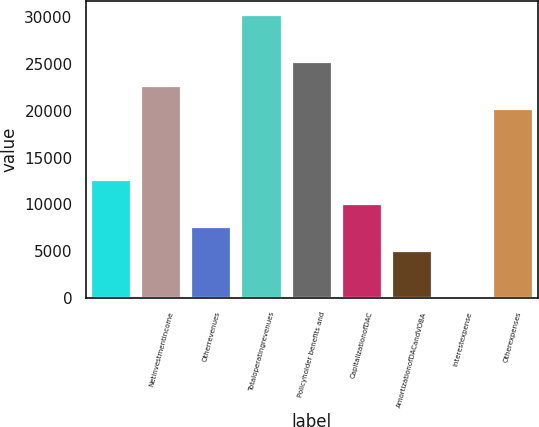Convert chart to OTSL. <chart><loc_0><loc_0><loc_500><loc_500><bar_chart><ecel><fcel>Netinvestmentincome<fcel>Otherrevenues<fcel>Totaloperatingrevenues<fcel>Policyholder benefits and<fcel>CapitalizationofDAC<fcel>AmortizationofDACandVOBA<fcel>Interestexpense<fcel>Otherexpenses<nl><fcel>12592<fcel>22661.6<fcel>7557.2<fcel>30213.8<fcel>25179<fcel>10074.6<fcel>5039.8<fcel>5<fcel>20144.2<nl></chart> 